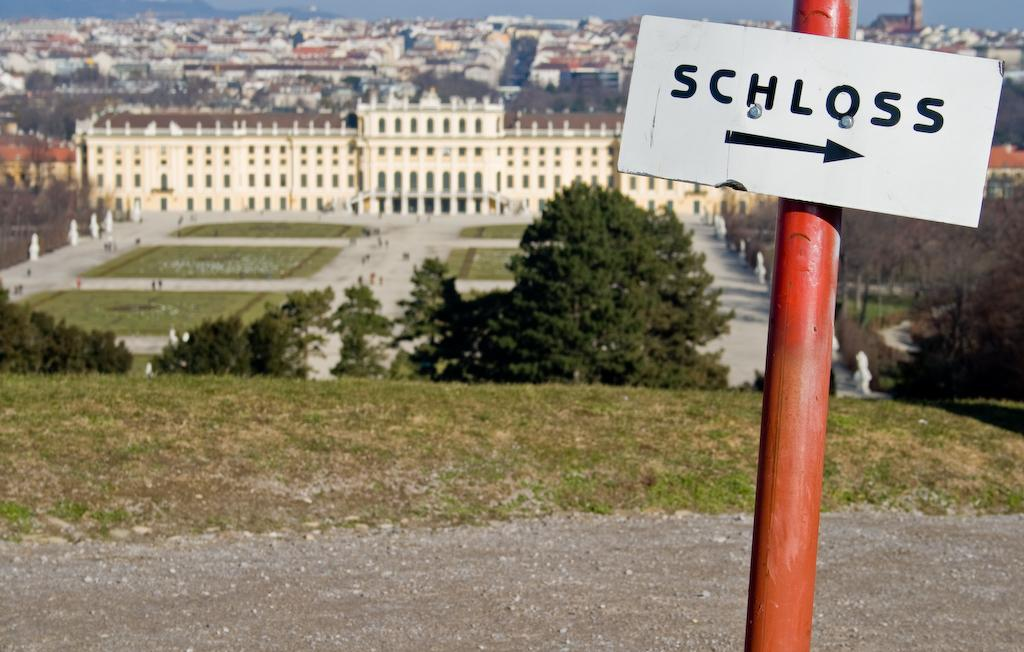<image>
Relay a brief, clear account of the picture shown. A sign with an arrow pointing to the right that says Schloss. 